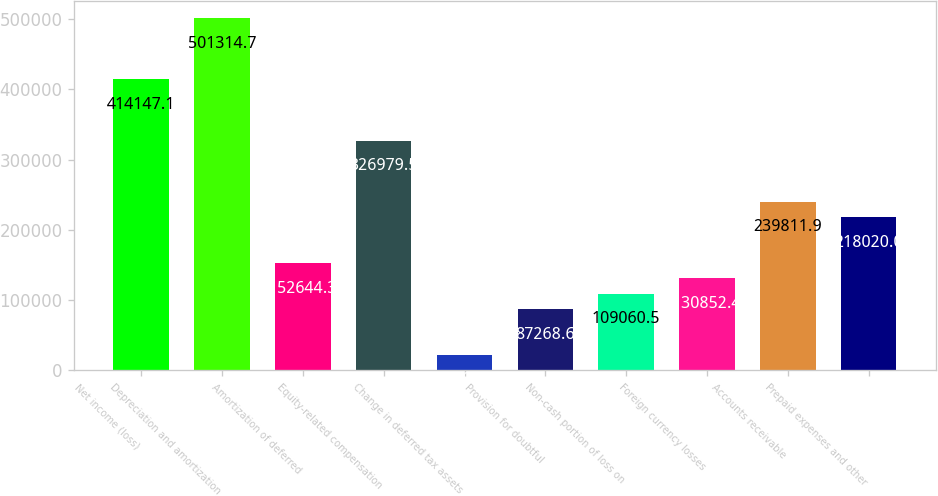Convert chart. <chart><loc_0><loc_0><loc_500><loc_500><bar_chart><fcel>Net income (loss)<fcel>Depreciation and amortization<fcel>Amortization of deferred<fcel>Equity-related compensation<fcel>Change in deferred tax assets<fcel>Provision for doubtful<fcel>Non-cash portion of loss on<fcel>Foreign currency losses<fcel>Accounts receivable<fcel>Prepaid expenses and other<nl><fcel>414147<fcel>501315<fcel>152644<fcel>326980<fcel>21892.9<fcel>87268.6<fcel>109060<fcel>130852<fcel>239812<fcel>218020<nl></chart> 